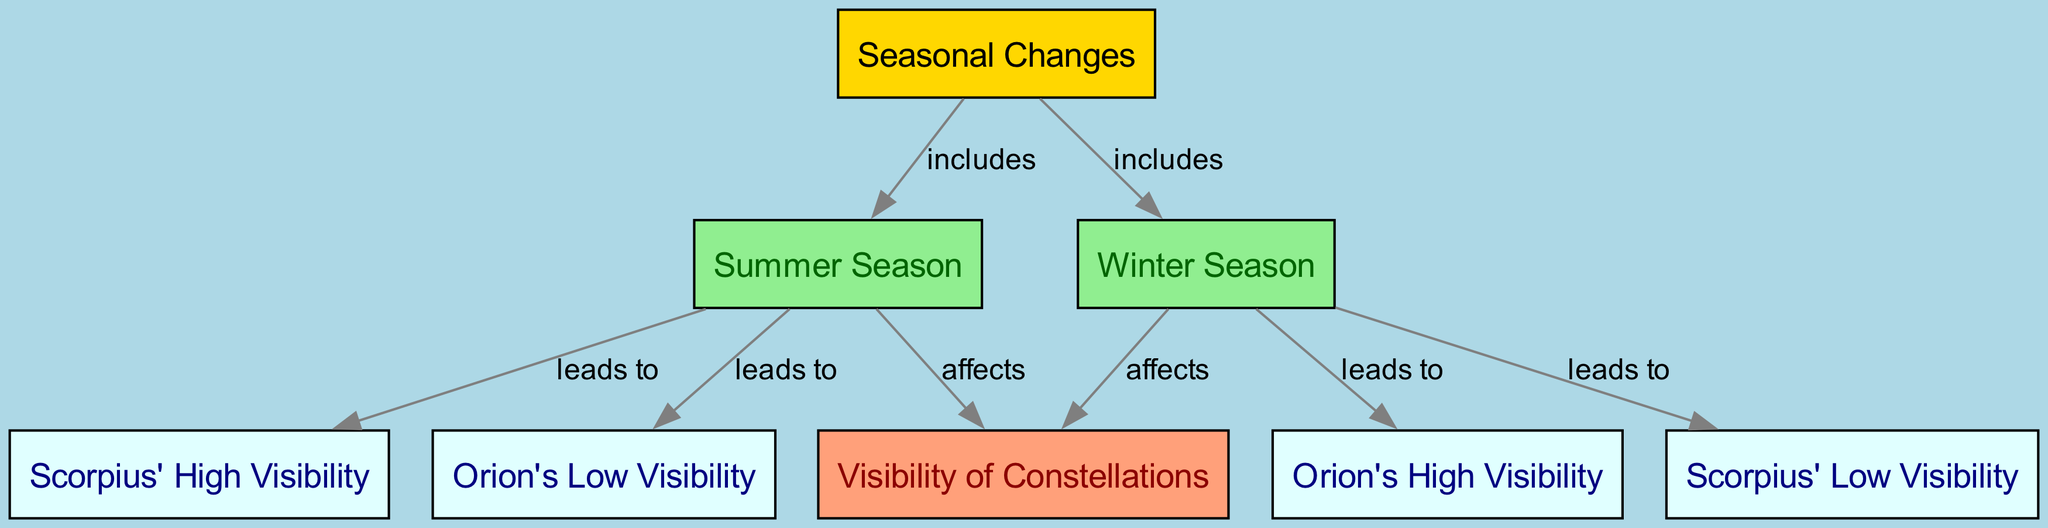What two seasons are included in the diagram? The diagram shows that "Seasonal Changes" includes "Winter Season" and "Summer Season." These nodes are directly connected to the "Seasonal Changes" node with the label "includes."
Answer: Winter Season, Summer Season How many total nodes are there in the diagram? By counting the 'nodes' listed, there are a total of 8 nodes including "Seasonal Changes," "Winter Season," "Summer Season," "Visibility of Constellations," "Orion's High Visibility," "Orion's Low Visibility," "Scorpius' High Visibility," and "Scorpius' Low Visibility."
Answer: 8 Which constellation has high visibility in winter? According to the relationships in the diagram, "Orion's High Visibility" is directly linked to "Winter Season" with the label "leads to," indicating it is visible during winter.
Answer: Orion's High Visibility What relationship exists between the summer season and Scorpius' visibility? The diagram indicates a direct lead from "Summer Season" to "Scorpius' High Visibility," meaning that summer affects visibility positively for Scorpius.
Answer: leads to What is the visibility of Orion during the summer season? The diagram shows that "Summer Season" leads to "Orion's Low Visibility." Therefore, Orion is not visible well in summer.
Answer: Low Visibility Which season affects visibility the most based on the diagram? Since both seasons affect the "Visibility of Constellations," the real determining factor is the leading outcomes: the Winter Season shows a high visibility for Orion, suggesting a stronger effect during winter compared to the summer effects on visibility.
Answer: Winter Season What color is the node for "Visibility of Constellations"? In the diagram, the node for "Visibility of Constellations" is filled with the color lightsalmon, distinguishing it from the others.
Answer: lightsalmon How many edges are connected to the "Winter Season"? By checking the diagram's edges, "Winter Season" connects to "Visibility of Constellations," "Orion's High Visibility," and "Scorpius' Low Visibility," totaling to three edges.
Answer: 3 